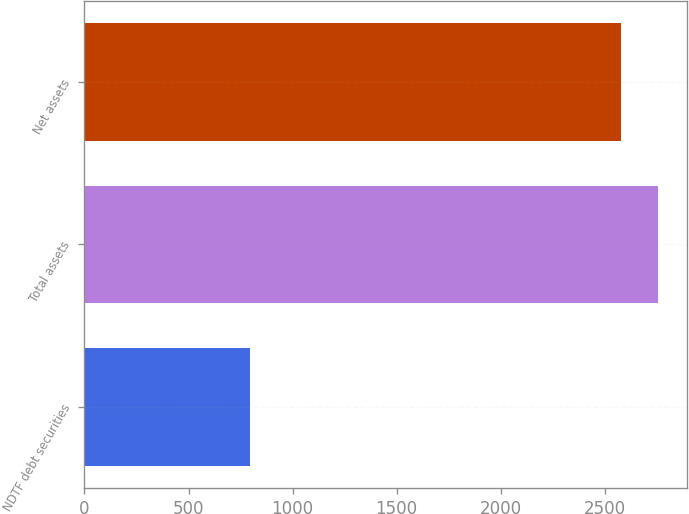Convert chart to OTSL. <chart><loc_0><loc_0><loc_500><loc_500><bar_chart><fcel>NDTF debt securities<fcel>Total assets<fcel>Net assets<nl><fcel>796<fcel>2755.8<fcel>2576<nl></chart> 